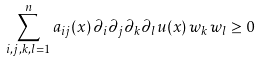<formula> <loc_0><loc_0><loc_500><loc_500>\sum _ { i , j , k , l = 1 } ^ { n } a _ { i j } ( x ) \, \partial _ { i } \partial _ { j } \partial _ { k } \partial _ { l } u ( x ) \, w _ { k } \, w _ { l } \geq 0</formula> 